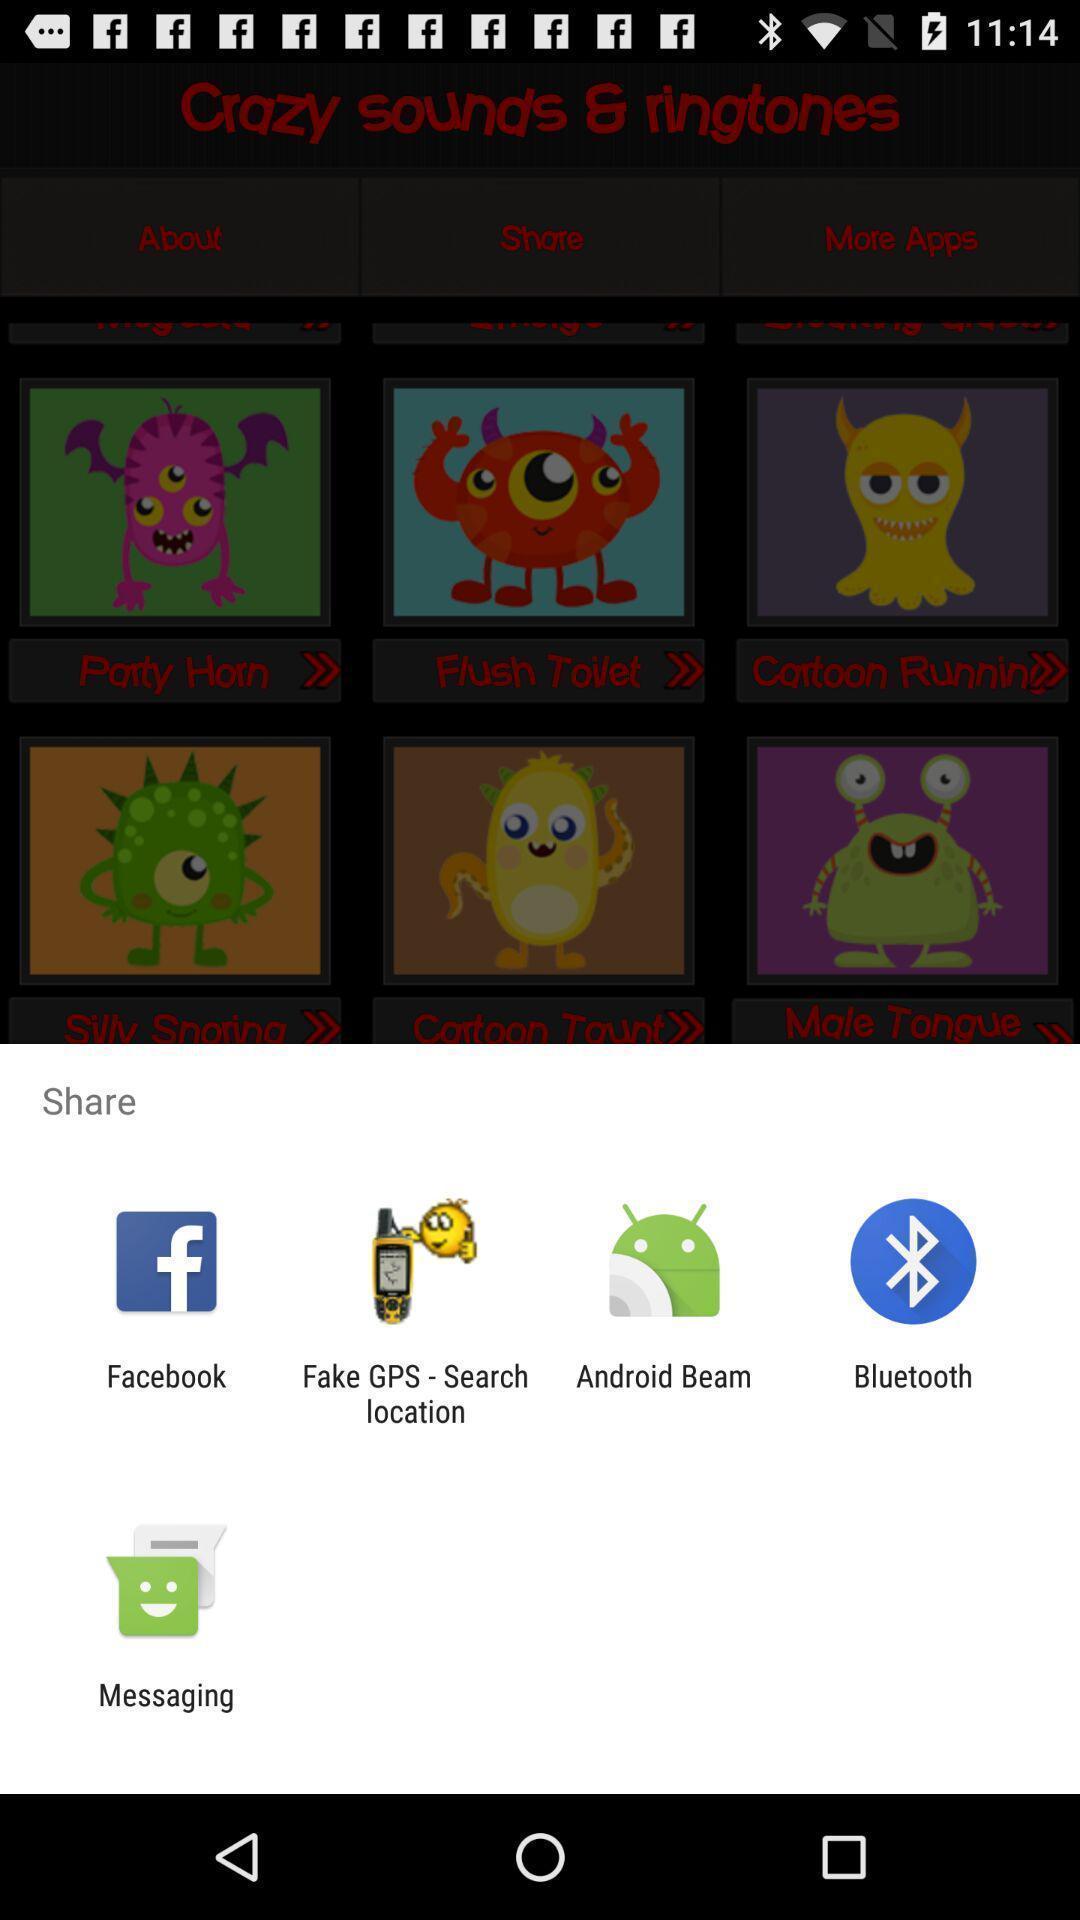What can you discern from this picture? Share information with different apps. 